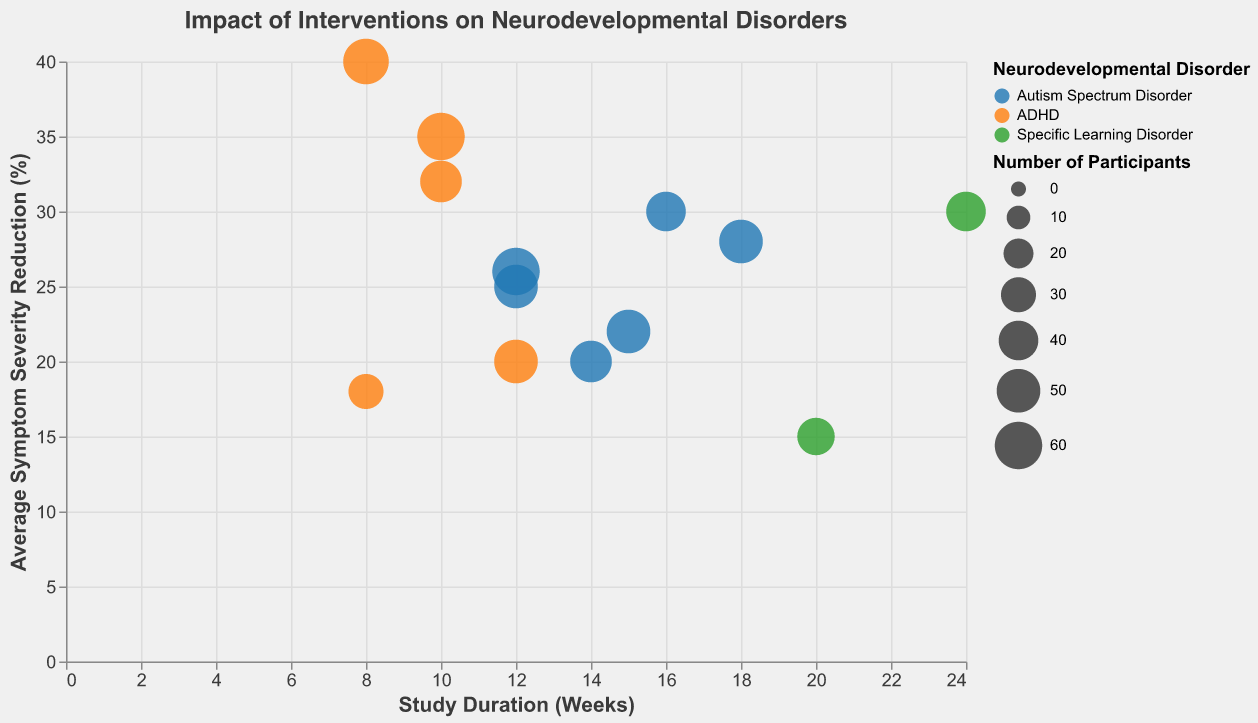How many intervention techniques are applied to Autism Spectrum Disorder? Count the number of distinct intervention techniques labeled for "Autism Spectrum Disorder" from the chart.
Answer: 6 Which neurodevelopmental disorder has the highest average symptom severity reduction? Compare the highest y-values (Average Symptom Severity Reduction) in the bubble chart for different colors representing the neurodevelopmental disorders.
Answer: ADHD What is the average study duration for interventions targeting Specific Learning Disorder? Calculate the average study duration by averaging the x-values (Study Duration Weeks) of the bubbles labeled for "Specific Learning Disorder."
(20 + 24) / 2
Answer: 22 weeks Which intervention for ADHD has the largest reduction in symptom severity, and what is the reduction percentage? Identify the largest bubble for ADHD (orange), which represents the highest average symptom severity reduction.
Answer: Medication (Methylphenidate), 40% Compare the average symptom severity reduction between Cognitive Behavioral Therapy (CBT) and Parental Training for Autism Spectrum Disorder. Identify and subtract the y-values for the two specific interventions targeting "Autism Spectrum Disorder" from the chart.
26 - 25
Answer: 1% What is the total number of participants in intervention studies for Autism Spectrum Disorder? Sum the size attributes of all bubbles representing "Autism Spectrum Disorder."
50 + 40 + 45 + 50 + 50 + 60
Answer: 295 Which intervention has the smallest number of participants, and for which disorder? Identify the smallest bubble in the chart and check its tooltip information for the neurodevelopmental disorder.
Answer: Mindfulness Training, ADHD What is the range of study durations across all interventions? Identify the minimum and maximum x-values (Study Duration Weeks) among all bubbles and calculate the range. The minimum is 8 weeks and the maximum is 24 weeks.
24 - 8
Answer: 16 weeks Which interventions have the highest average symptom severity reduction for Autism Spectrum Disorder, and how long were their durations? Identify the highest y-values among the blue bubbles, and note their x-values for their durations.
Speech Therapy (16 weeks) and Parental Training (12 weeks)
Answer: Speech Therapy (16 weeks) and Parental Training (12 weeks) 